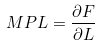<formula> <loc_0><loc_0><loc_500><loc_500>M P L = \frac { \partial F } { \partial L }</formula> 